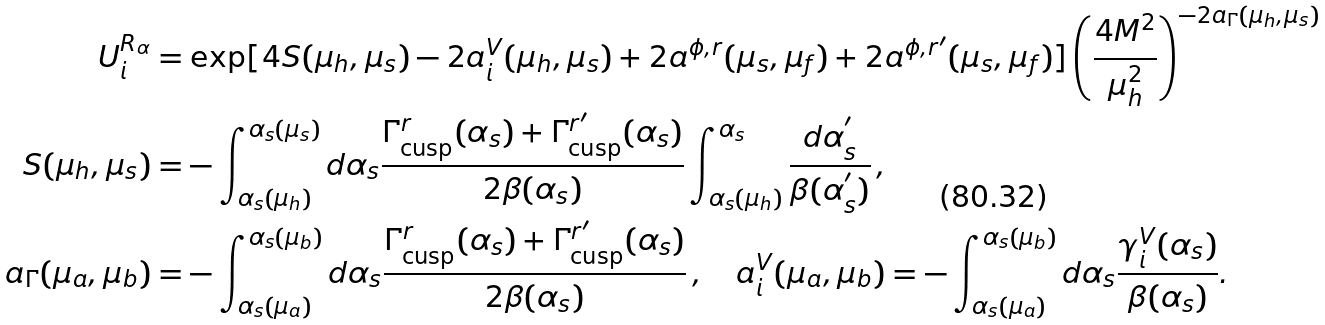<formula> <loc_0><loc_0><loc_500><loc_500>U _ { i } ^ { R _ { \alpha } } & = \exp [ 4 S ( \mu _ { h } , \mu _ { s } ) - 2 a _ { i } ^ { V } ( \mu _ { h } , \mu _ { s } ) + 2 a ^ { \phi , r } ( \mu _ { s } , \mu _ { f } ) + 2 a ^ { \phi , r ^ { \prime } } ( \mu _ { s } , \mu _ { f } ) ] \left ( \frac { 4 M ^ { 2 } } { \mu _ { h } ^ { 2 } } \right ) ^ { - 2 a _ { \Gamma } ( \mu _ { h } , \mu _ { s } ) } \\ S ( \mu _ { h } , \mu _ { s } ) & = - \int _ { \alpha _ { s } ( \mu _ { h } ) } ^ { \alpha _ { s } ( \mu _ { s } ) } d \alpha _ { s } \frac { \Gamma ^ { r } _ { \text {\text {cusp}} } ( \alpha _ { s } ) + \Gamma ^ { r ^ { \prime } } _ { \text {\text {cusp}} } ( \alpha _ { s } ) } { 2 \beta ( \alpha _ { s } ) } \int _ { \alpha _ { s } ( \mu _ { h } ) } ^ { \alpha _ { s } } \frac { d \alpha _ { s } ^ { ^ { \prime } } } { \beta ( \alpha _ { s } ^ { ^ { \prime } } ) } \, , \\ a _ { \Gamma } ( \mu _ { a } , \mu _ { b } ) & = - \int _ { \alpha _ { s } ( \mu _ { a } ) } ^ { \alpha _ { s } ( \mu _ { b } ) } d \alpha _ { s } \frac { \Gamma ^ { r } _ { \text {\text {cusp}} } ( \alpha _ { s } ) + \Gamma ^ { r ^ { \prime } } _ { \text {\text {cusp}} } ( \alpha _ { s } ) } { 2 \beta ( \alpha _ { s } ) } \, , \quad a ^ { V } _ { i } ( \mu _ { a } , \mu _ { b } ) = - \int _ { \alpha _ { s } ( \mu _ { a } ) } ^ { \alpha _ { s } ( \mu _ { b } ) } d \alpha _ { s } \frac { \gamma _ { i } ^ { V } ( \alpha _ { s } ) } { \beta ( \alpha _ { s } ) } .</formula> 